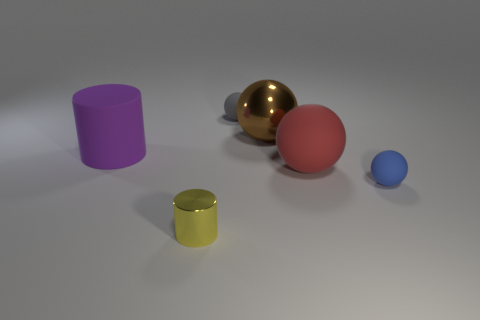The matte thing that is in front of the big brown object and to the left of the large brown ball has what shape?
Your answer should be very brief. Cylinder. What is the size of the blue thing that is made of the same material as the red ball?
Your answer should be compact. Small. Is the number of tiny gray things less than the number of tiny blue metal cylinders?
Your answer should be compact. No. What is the material of the brown thing to the right of the tiny ball that is behind the ball in front of the large red rubber sphere?
Your answer should be compact. Metal. Are the small sphere to the right of the gray thing and the big thing on the left side of the large metal sphere made of the same material?
Your response must be concise. Yes. What size is the object that is both to the right of the gray ball and behind the purple matte object?
Your answer should be very brief. Large. What is the material of the blue object that is the same size as the gray thing?
Offer a terse response. Rubber. There is a matte object that is on the left side of the small rubber object that is behind the big metal object; what number of large red objects are in front of it?
Keep it short and to the point. 1. Is the color of the big sphere that is behind the large cylinder the same as the big thing that is on the left side of the small metal cylinder?
Make the answer very short. No. What is the color of the matte thing that is both right of the large purple rubber cylinder and behind the red ball?
Your answer should be very brief. Gray. 